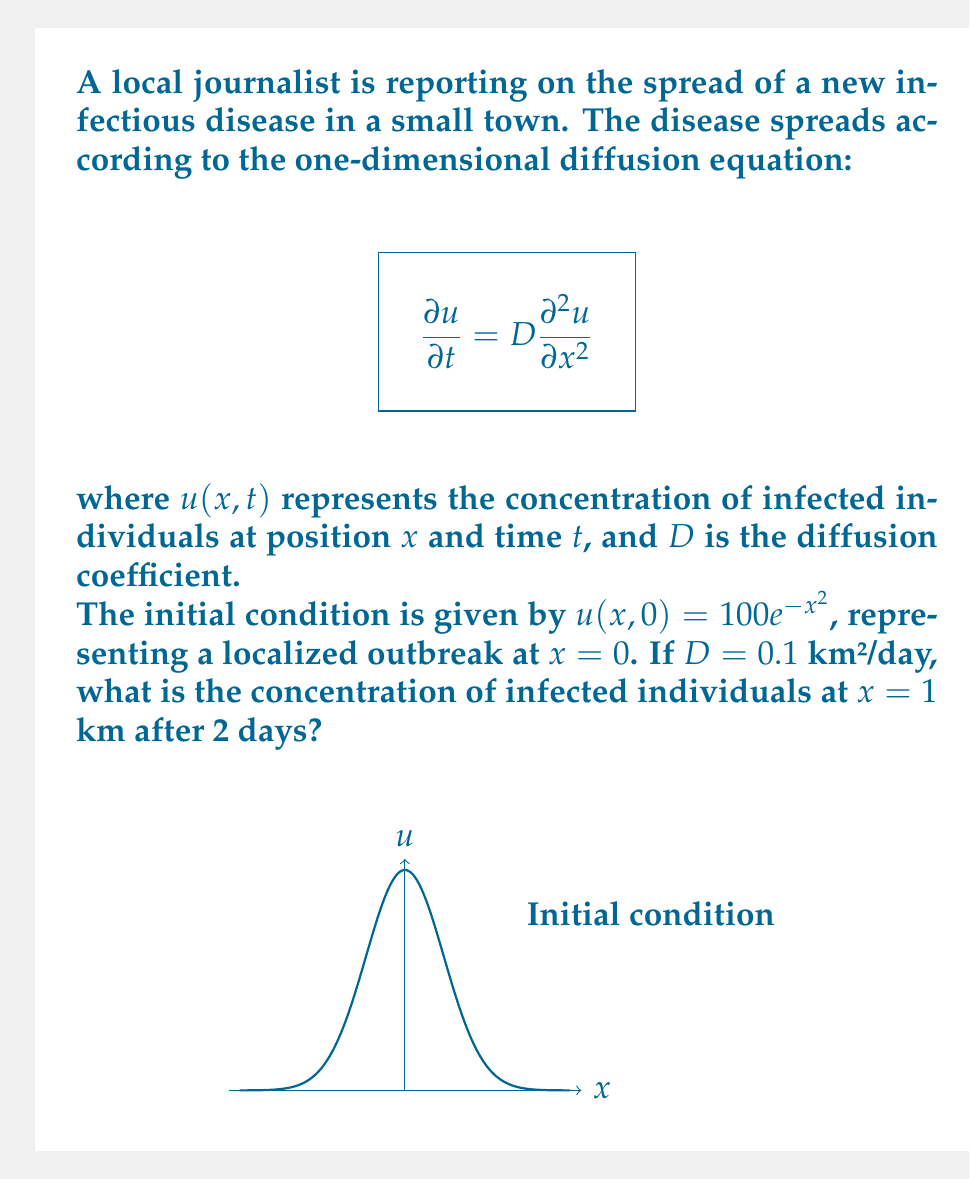Give your solution to this math problem. To solve this problem, we'll use the fundamental solution of the diffusion equation:

1) The solution to the diffusion equation with initial condition $u(x,0) = \delta(x)$ (where $\delta(x)$ is the Dirac delta function) is:

   $$u(x,t) = \frac{1}{\sqrt{4\pi Dt}} e^{-\frac{x^2}{4Dt}}$$

2) For our initial condition $u(x,0) = 100e^{-x^2}$, we can use the principle of superposition. The solution is the convolution of the initial condition with the fundamental solution:

   $$u(x,t) = \frac{100}{\sqrt{4\pi Dt}} \int_{-\infty}^{\infty} e^{-y^2} e^{-\frac{(x-y)^2}{4Dt}} dy$$

3) This integral can be evaluated to give:

   $$u(x,t) = \frac{100}{\sqrt{1+4Dt}} e^{-\frac{x^2}{1+4Dt}}$$

4) Now, we can substitute our values: $D = 0.1$ km²/day, $t = 2$ days, and $x = 1$ km:

   $$u(1,2) = \frac{100}{\sqrt{1+4(0.1)(2)}} e^{-\frac{1^2}{1+4(0.1)(2)}}$$

5) Simplify:
   $$u(1,2) = \frac{100}{\sqrt{1.8}} e^{-\frac{1}{1.8}}$$

6) Calculate:
   $$u(1,2) \approx 74.54 \cdot 0.5733 \approx 42.73$$

Therefore, the concentration of infected individuals at $x = 1$ km after 2 days is approximately 42.73 individuals per unit area.
Answer: 42.73 individuals per unit area 